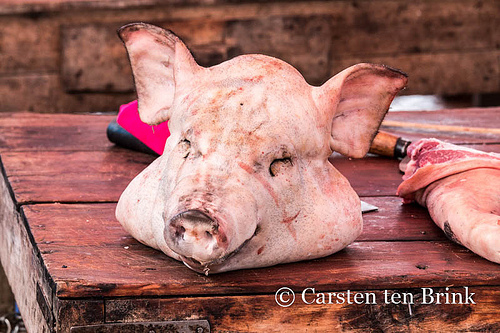<image>
Can you confirm if the pig head is above the table? No. The pig head is not positioned above the table. The vertical arrangement shows a different relationship. Where is the pig in relation to the table? Is it on the table? Yes. Looking at the image, I can see the pig is positioned on top of the table, with the table providing support. 